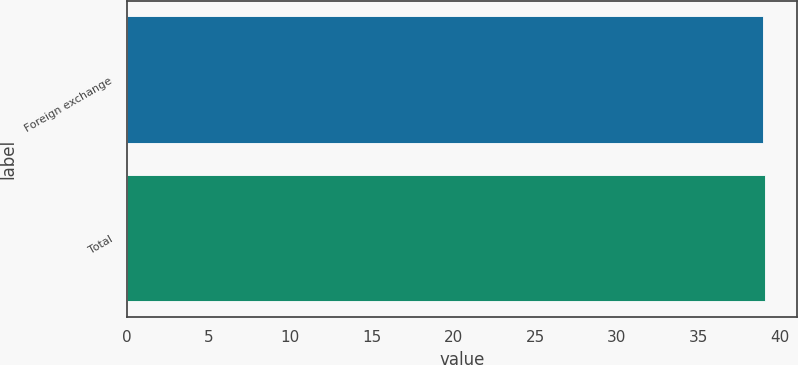Convert chart. <chart><loc_0><loc_0><loc_500><loc_500><bar_chart><fcel>Foreign exchange<fcel>Total<nl><fcel>39<fcel>39.1<nl></chart> 